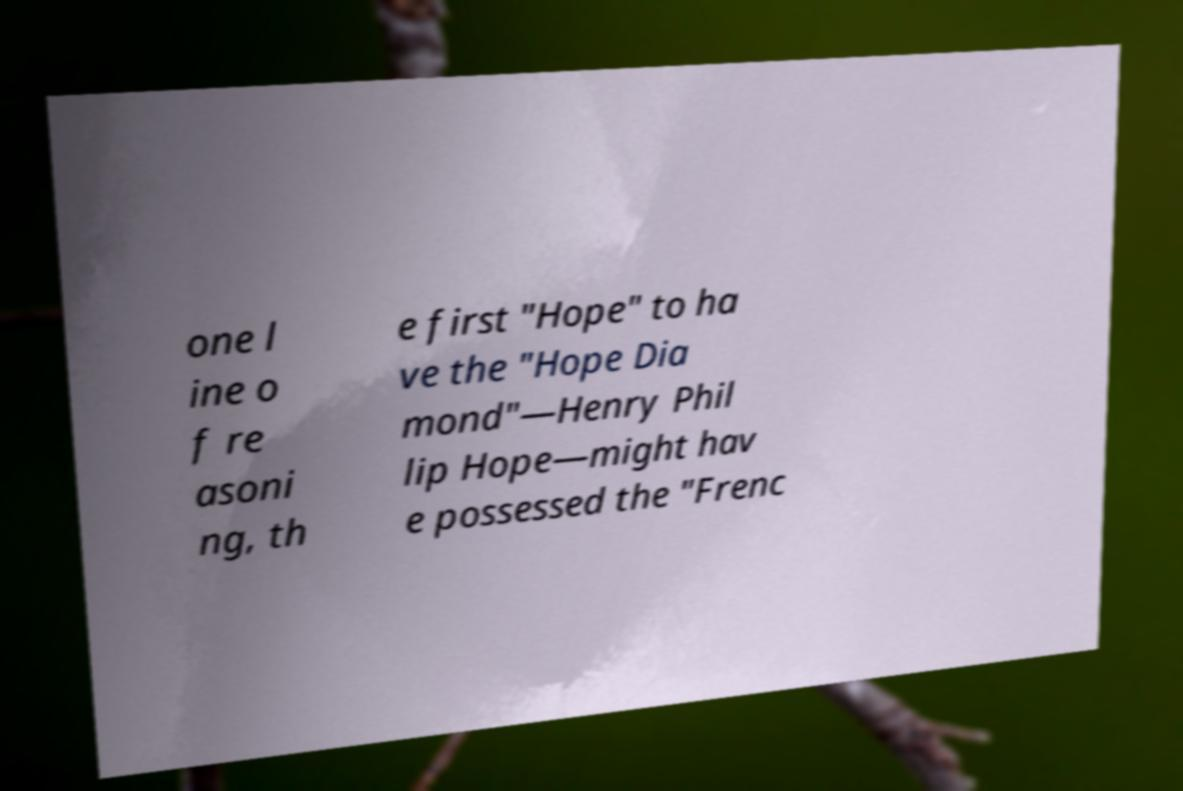Could you extract and type out the text from this image? one l ine o f re asoni ng, th e first "Hope" to ha ve the "Hope Dia mond"—Henry Phil lip Hope—might hav e possessed the "Frenc 